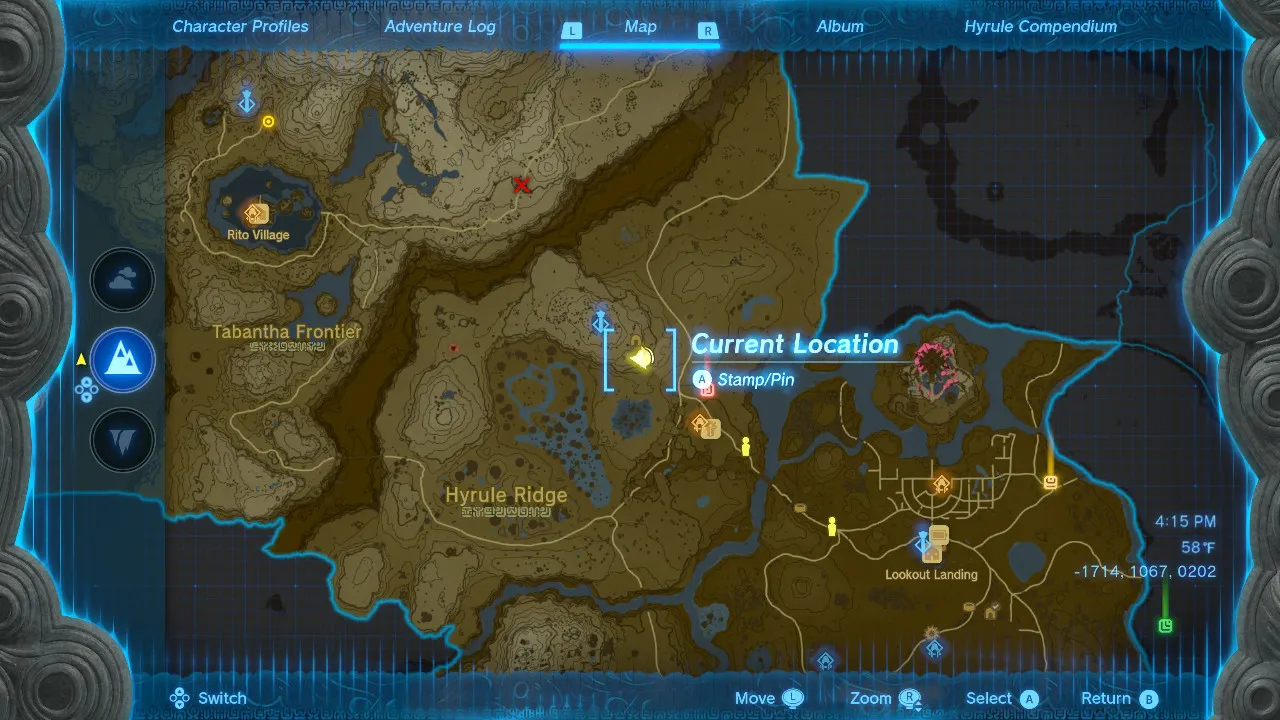Given my horse's location on this map, what is the quickest route to reach it? The quickest route to reach your horse is to head south from your current location until you reach the road. Follow the road west until you reach the bridge. Cross the bridge and continue west until you reach the next road. Turn south onto this road and follow it until you reach your horse. 